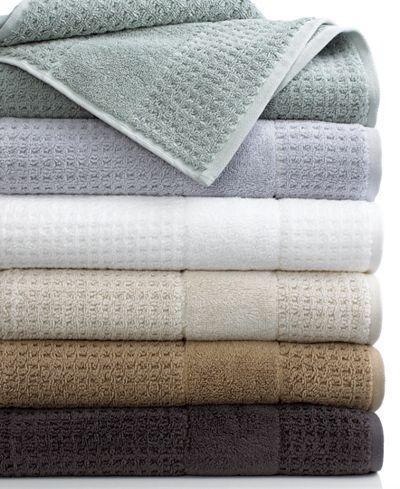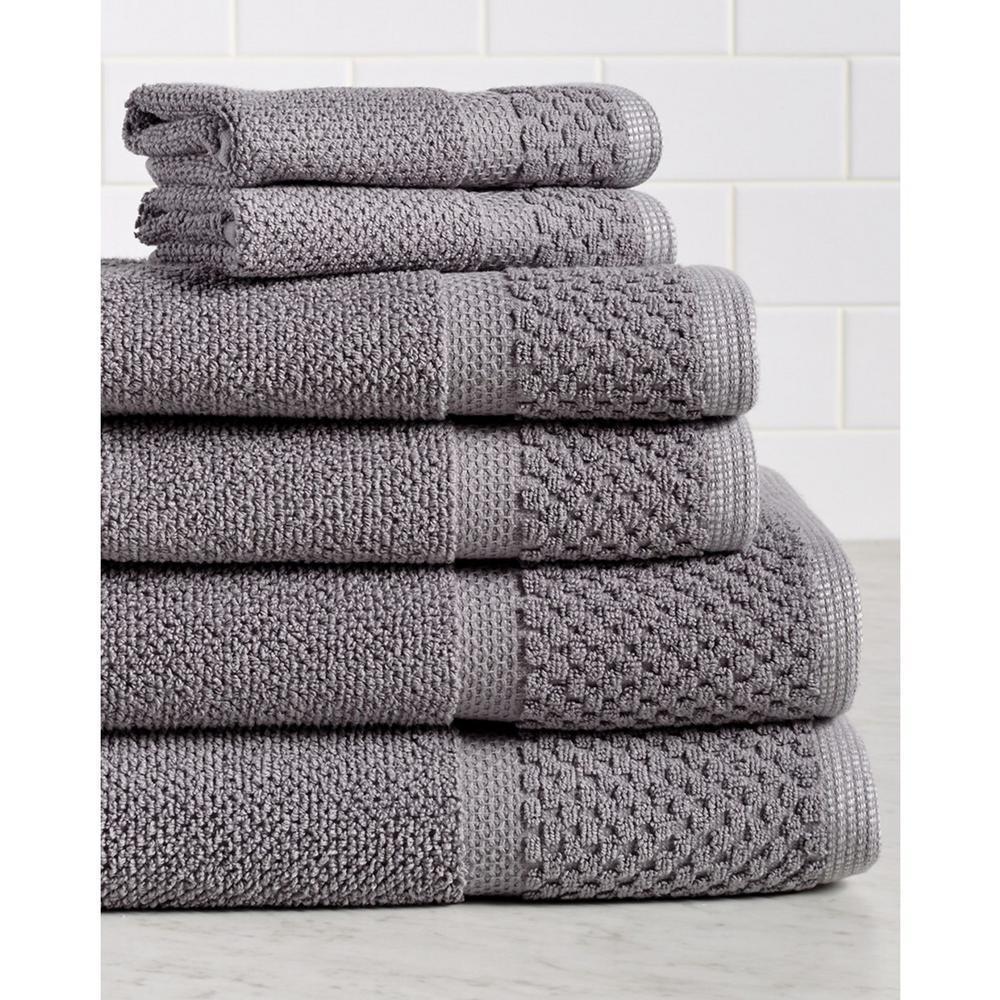The first image is the image on the left, the second image is the image on the right. Given the left and right images, does the statement "The left image shows a stack of four white folded towels, and the right image shows a stack of at least 8 folded towels of different solid colors." hold true? Answer yes or no. No. The first image is the image on the left, the second image is the image on the right. Examine the images to the left and right. Is the description "There are multiple colors of towels in the right image." accurate? Answer yes or no. No. 